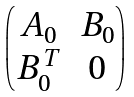<formula> <loc_0><loc_0><loc_500><loc_500>\begin{pmatrix} A _ { 0 } & B _ { 0 } \\ B _ { 0 } ^ { T } & 0 \end{pmatrix}</formula> 